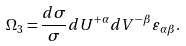Convert formula to latex. <formula><loc_0><loc_0><loc_500><loc_500>\Omega _ { 3 } = \frac { d \sigma } { \sigma } d U ^ { + \alpha } d V ^ { - \beta } \varepsilon _ { \alpha \beta } .</formula> 